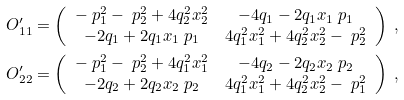<formula> <loc_0><loc_0><loc_500><loc_500>& O ^ { \prime } _ { 1 1 } = \left ( \begin{array} { c c } - \ p _ { 1 } ^ { 2 } - \ p _ { 2 } ^ { 2 } + 4 q _ { 2 } ^ { 2 } x _ { 2 } ^ { 2 } & - 4 q _ { 1 } - 2 q _ { 1 } x _ { 1 } \ p _ { 1 } \\ - 2 q _ { 1 } + 2 q _ { 1 } x _ { 1 } \ p _ { 1 } & 4 q _ { 1 } ^ { 2 } x _ { 1 } ^ { 2 } + 4 q _ { 2 } ^ { 2 } x _ { 2 } ^ { 2 } - \ p _ { 2 } ^ { 2 } \end{array} \right ) \ , \\ & O ^ { \prime } _ { 2 2 } = \left ( \begin{array} { c c } - \ p _ { 1 } ^ { 2 } - \ p _ { 2 } ^ { 2 } + 4 q _ { 1 } ^ { 2 } x _ { 1 } ^ { 2 } & - 4 q _ { 2 } - 2 q _ { 2 } x _ { 2 } \ p _ { 2 } \\ - 2 q _ { 2 } + 2 q _ { 2 } x _ { 2 } \ p _ { 2 } & 4 q _ { 1 } ^ { 2 } x _ { 1 } ^ { 2 } + 4 q _ { 2 } ^ { 2 } x _ { 2 } ^ { 2 } - \ p _ { 1 } ^ { 2 } \end{array} \right ) \ ,</formula> 